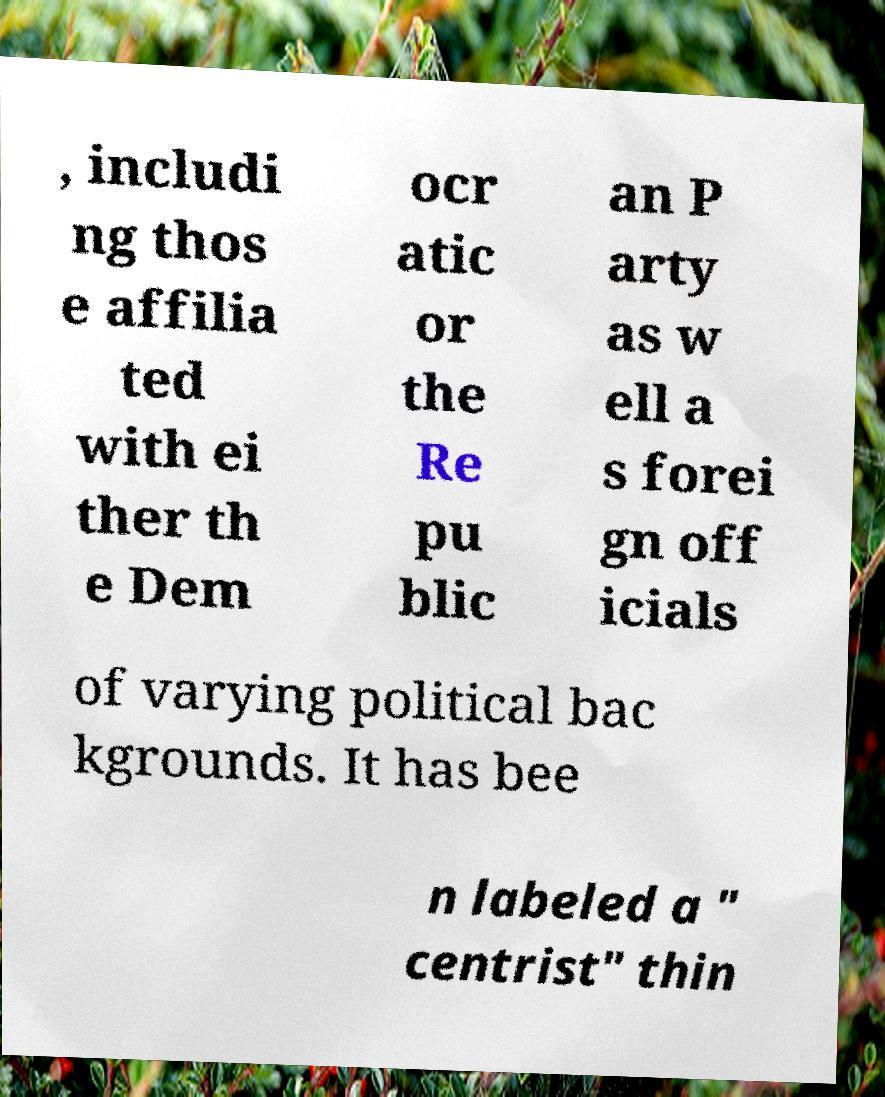For documentation purposes, I need the text within this image transcribed. Could you provide that? , includi ng thos e affilia ted with ei ther th e Dem ocr atic or the Re pu blic an P arty as w ell a s forei gn off icials of varying political bac kgrounds. It has bee n labeled a " centrist" thin 